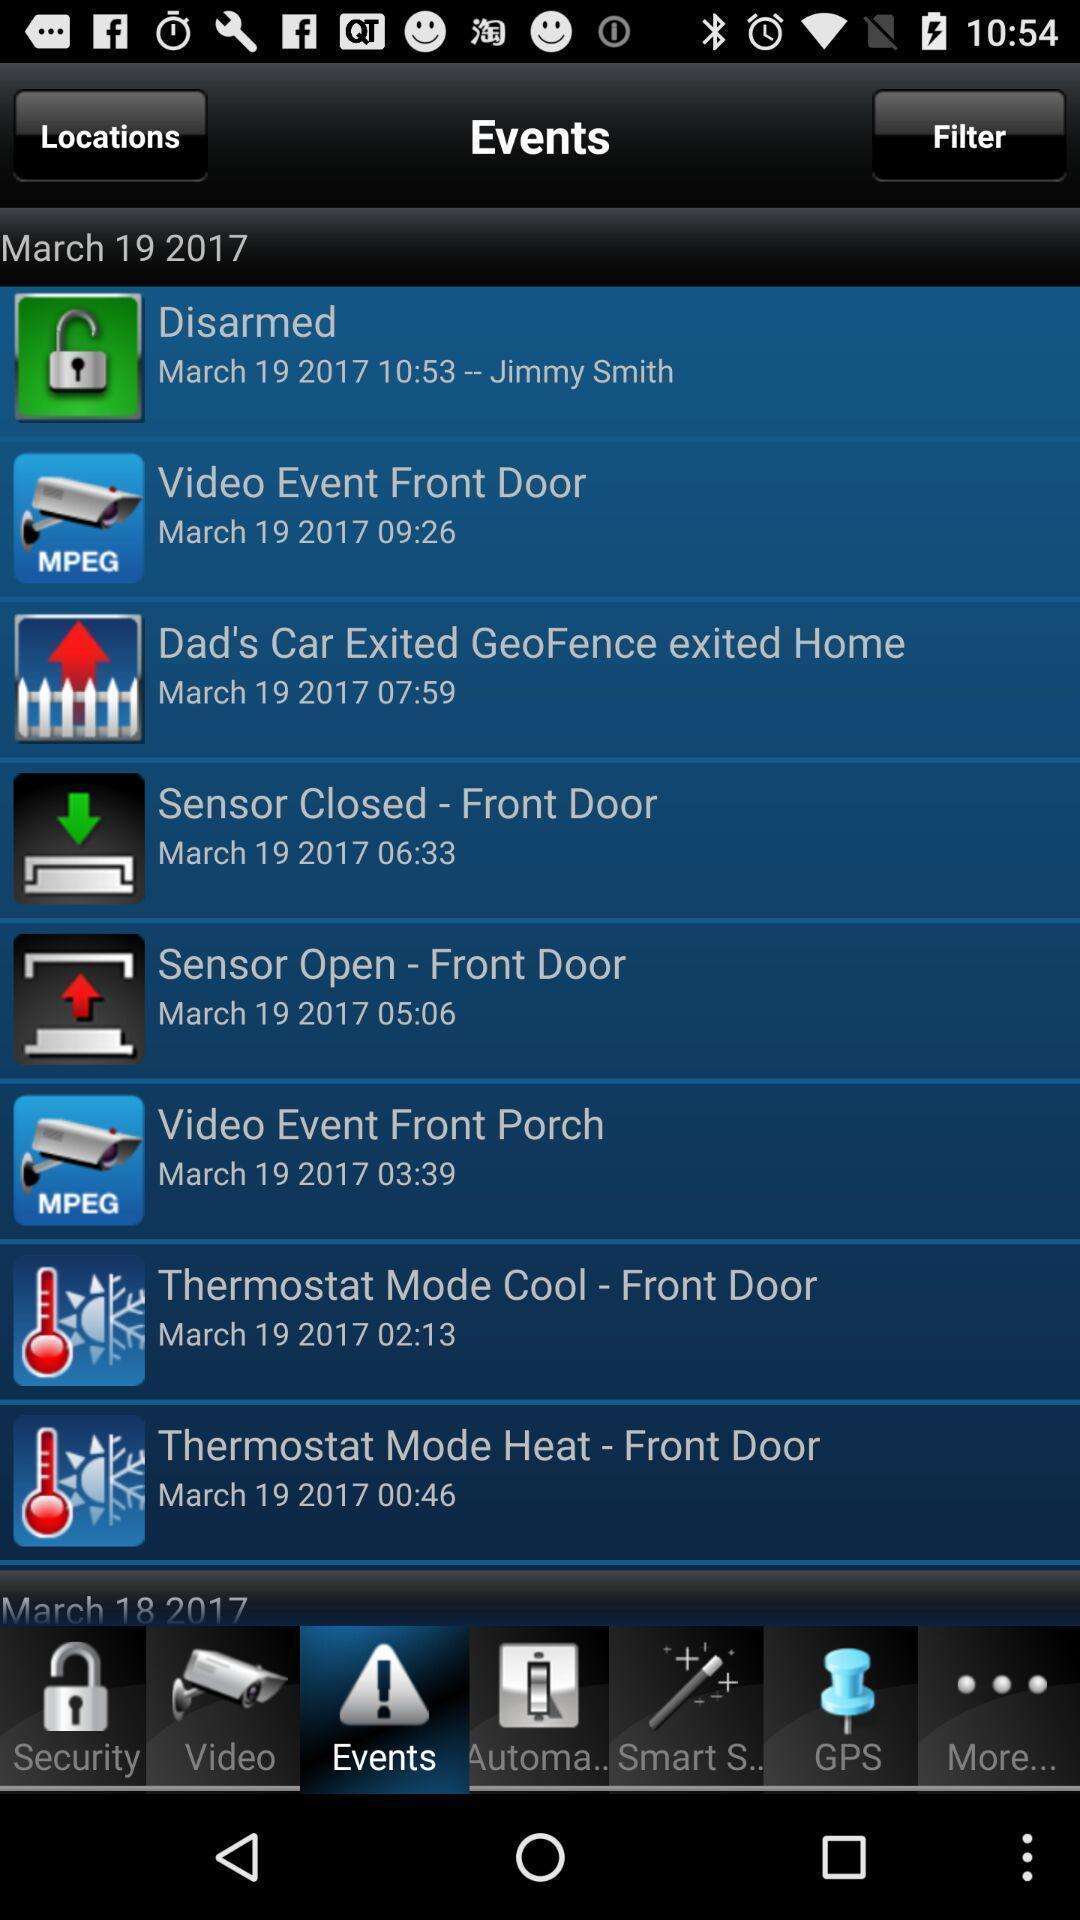What can you discern from this picture? Page showing list of events on a service app. 